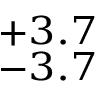Convert formula to latex. <formula><loc_0><loc_0><loc_500><loc_500>^ { + 3 . 7 } _ { - 3 . 7 }</formula> 